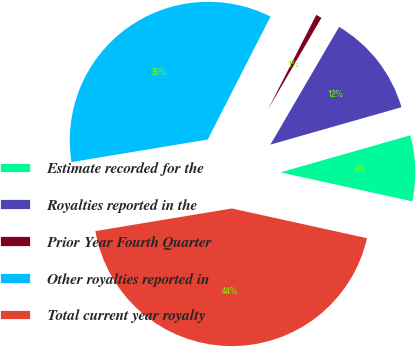Convert chart. <chart><loc_0><loc_0><loc_500><loc_500><pie_chart><fcel>Estimate recorded for the<fcel>Royalties reported in the<fcel>Prior Year Fourth Quarter<fcel>Other royalties reported in<fcel>Total current year royalty<nl><fcel>7.87%<fcel>12.17%<fcel>0.89%<fcel>35.13%<fcel>43.94%<nl></chart> 